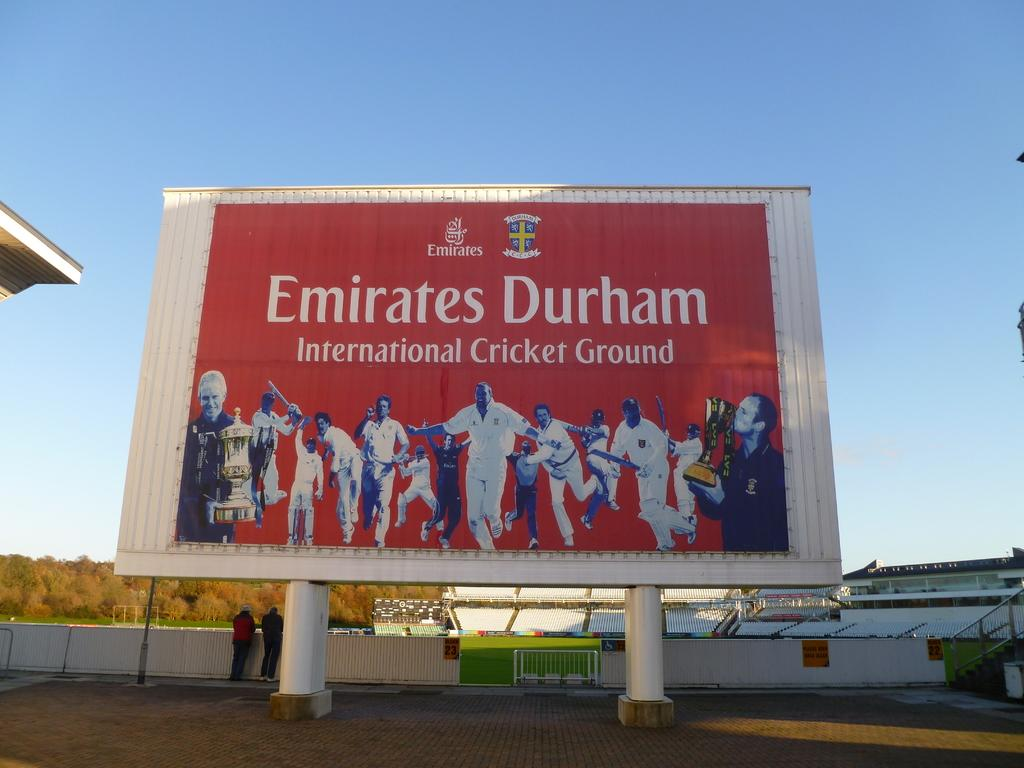<image>
Relay a brief, clear account of the picture shown. a billboard with a group of cricket players featured on it 